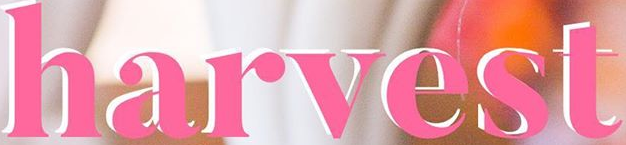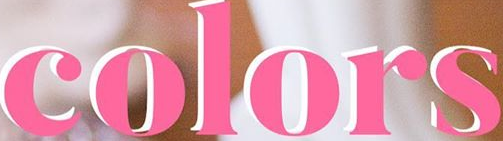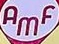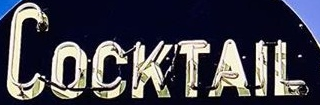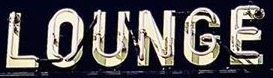Transcribe the words shown in these images in order, separated by a semicolon. harvest; colors; AMF; COCKTAIL; LOUNGE 